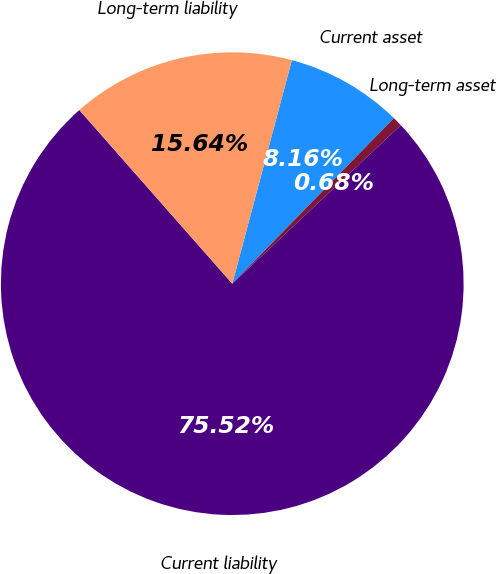<chart> <loc_0><loc_0><loc_500><loc_500><pie_chart><fcel>Current asset<fcel>Long-term asset<fcel>Current liability<fcel>Long-term liability<nl><fcel>8.16%<fcel>0.68%<fcel>75.52%<fcel>15.64%<nl></chart> 